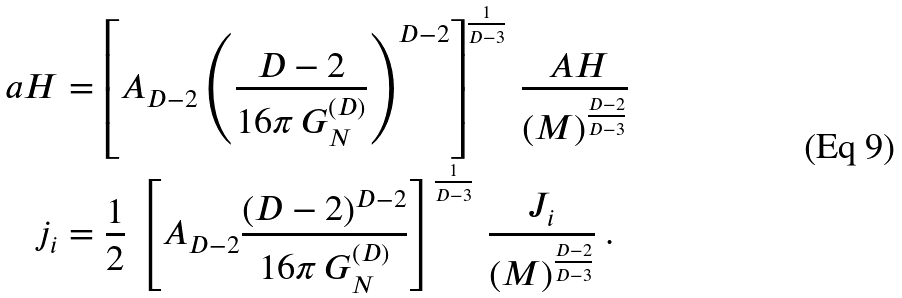<formula> <loc_0><loc_0><loc_500><loc_500>\ a H & = \left [ A _ { D - 2 } \left ( \frac { D - 2 } { 1 6 \pi \, G ^ { ( D ) } _ { N } } \right ) ^ { D - 2 } \right ] ^ { \frac { 1 } { D - 3 } } \, \frac { \ A H } { \left ( M \right ) ^ { \frac { D - 2 } { D - 3 } } } \\ j _ { i } & = \frac { 1 } { 2 } \, \left [ A _ { D - 2 } \frac { ( D - 2 ) ^ { D - 2 } } { 1 6 \pi \, G ^ { ( D ) } _ { N } } \right ] ^ { \frac { 1 } { D - 3 } } \, \frac { J _ { i } } { \left ( M \right ) ^ { \frac { D - 2 } { D - 3 } } } \ .</formula> 